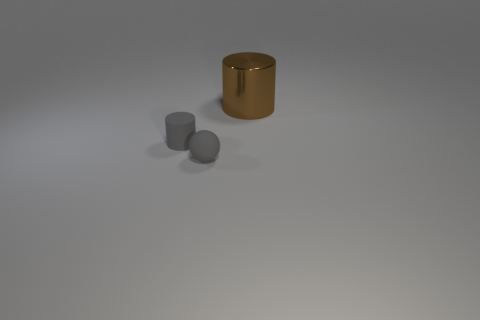How many spheres are the same material as the tiny cylinder?
Your response must be concise. 1. There is a tiny gray rubber thing right of the cylinder left of the large cylinder; are there any large shiny objects that are on the right side of it?
Give a very brief answer. Yes. What number of cubes are tiny things or big metal things?
Ensure brevity in your answer.  0. There is a large metallic object; is it the same shape as the gray rubber object behind the gray matte sphere?
Your answer should be compact. Yes. Are there fewer brown cylinders in front of the shiny cylinder than rubber objects?
Offer a terse response. Yes. There is a gray matte sphere; are there any tiny gray objects left of it?
Your answer should be compact. Yes. Is there a tiny matte object that has the same shape as the big object?
Keep it short and to the point. Yes. There is a object that is the same size as the gray rubber ball; what is its shape?
Your answer should be compact. Cylinder. How many objects are objects that are behind the rubber sphere or tiny brown things?
Your answer should be compact. 2. Do the matte cylinder and the small rubber sphere have the same color?
Give a very brief answer. Yes. 